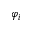Convert formula to latex. <formula><loc_0><loc_0><loc_500><loc_500>\varphi _ { i }</formula> 